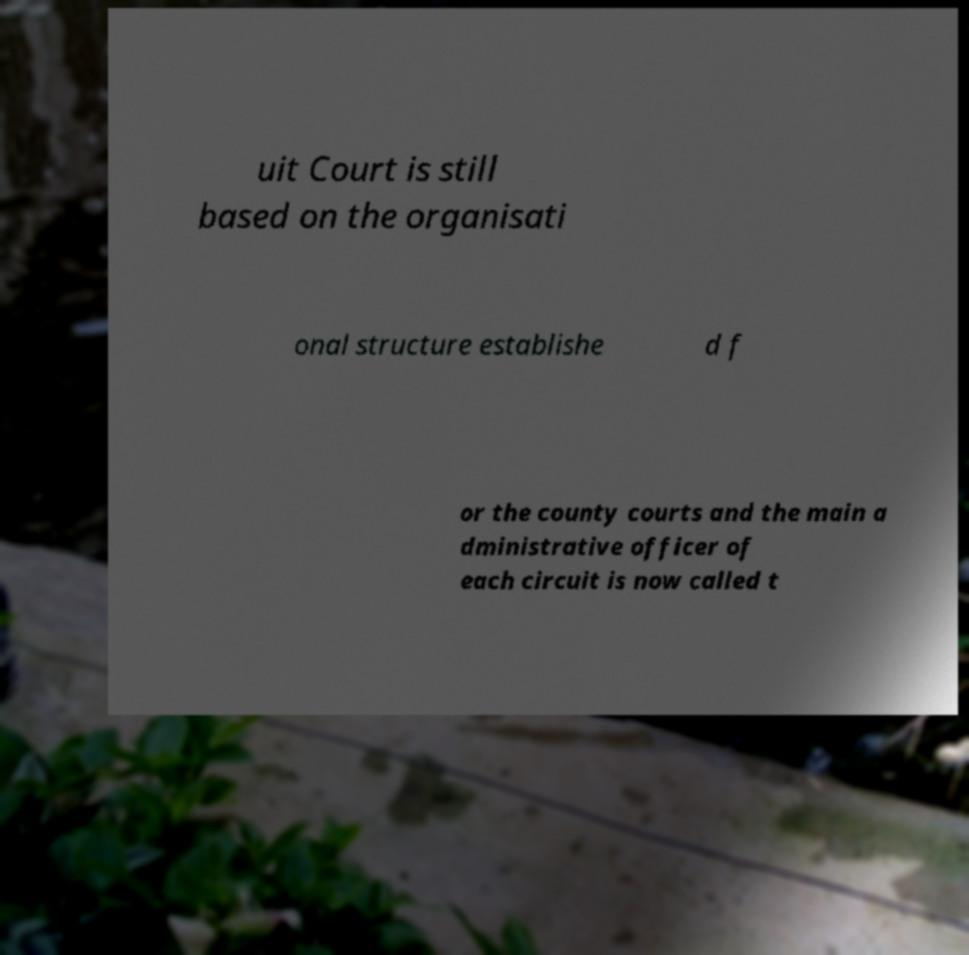There's text embedded in this image that I need extracted. Can you transcribe it verbatim? uit Court is still based on the organisati onal structure establishe d f or the county courts and the main a dministrative officer of each circuit is now called t 